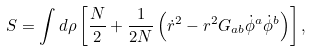<formula> <loc_0><loc_0><loc_500><loc_500>S = \int d \rho \left [ \frac { N } { 2 } + \frac { 1 } { 2 N } \left ( \dot { r } ^ { 2 } - r ^ { 2 } G _ { a b } \dot { \phi } ^ { a } \dot { \phi } ^ { b } \right ) \right ] ,</formula> 